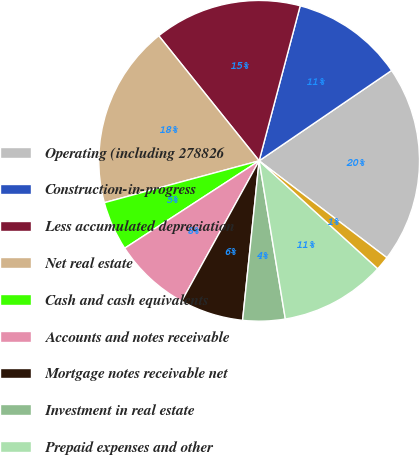<chart> <loc_0><loc_0><loc_500><loc_500><pie_chart><fcel>Operating (including 278826<fcel>Construction-in-progress<fcel>Less accumulated depreciation<fcel>Net real estate<fcel>Cash and cash equivalents<fcel>Accounts and notes receivable<fcel>Mortgage notes receivable net<fcel>Investment in real estate<fcel>Prepaid expenses and other<fcel>Debt issuance costs net of<nl><fcel>19.86%<fcel>11.35%<fcel>14.89%<fcel>18.44%<fcel>4.97%<fcel>7.8%<fcel>6.38%<fcel>4.26%<fcel>10.64%<fcel>1.42%<nl></chart> 